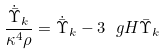<formula> <loc_0><loc_0><loc_500><loc_500>\frac { \dot { \bar { \Upsilon } } _ { k } } { \kappa ^ { 4 } \rho } = \dot { \bar { \Upsilon } } _ { k } - 3 \ g H \bar { \Upsilon } _ { k }</formula> 